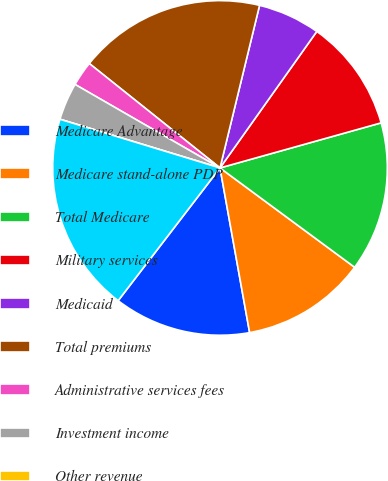<chart> <loc_0><loc_0><loc_500><loc_500><pie_chart><fcel>Medicare Advantage<fcel>Medicare stand-alone PDP<fcel>Total Medicare<fcel>Military services<fcel>Medicaid<fcel>Total premiums<fcel>Administrative services fees<fcel>Investment income<fcel>Other revenue<fcel>Total revenues<nl><fcel>13.25%<fcel>12.05%<fcel>14.46%<fcel>10.84%<fcel>6.02%<fcel>18.07%<fcel>2.41%<fcel>3.62%<fcel>0.0%<fcel>19.28%<nl></chart> 